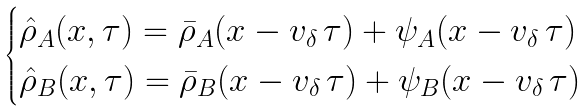<formula> <loc_0><loc_0><loc_500><loc_500>\begin{cases} \hat { \rho } _ { A } ( x , \tau ) = \bar { \rho } _ { A } ( x - v _ { \delta } \, \tau ) + \psi _ { A } ( x - v _ { \delta } \, \tau ) \\ \hat { \rho } _ { B } ( x , \tau ) = \bar { \rho } _ { B } ( x - v _ { \delta } \, \tau ) + \psi _ { B } ( x - v _ { \delta } \, \tau ) \end{cases}</formula> 